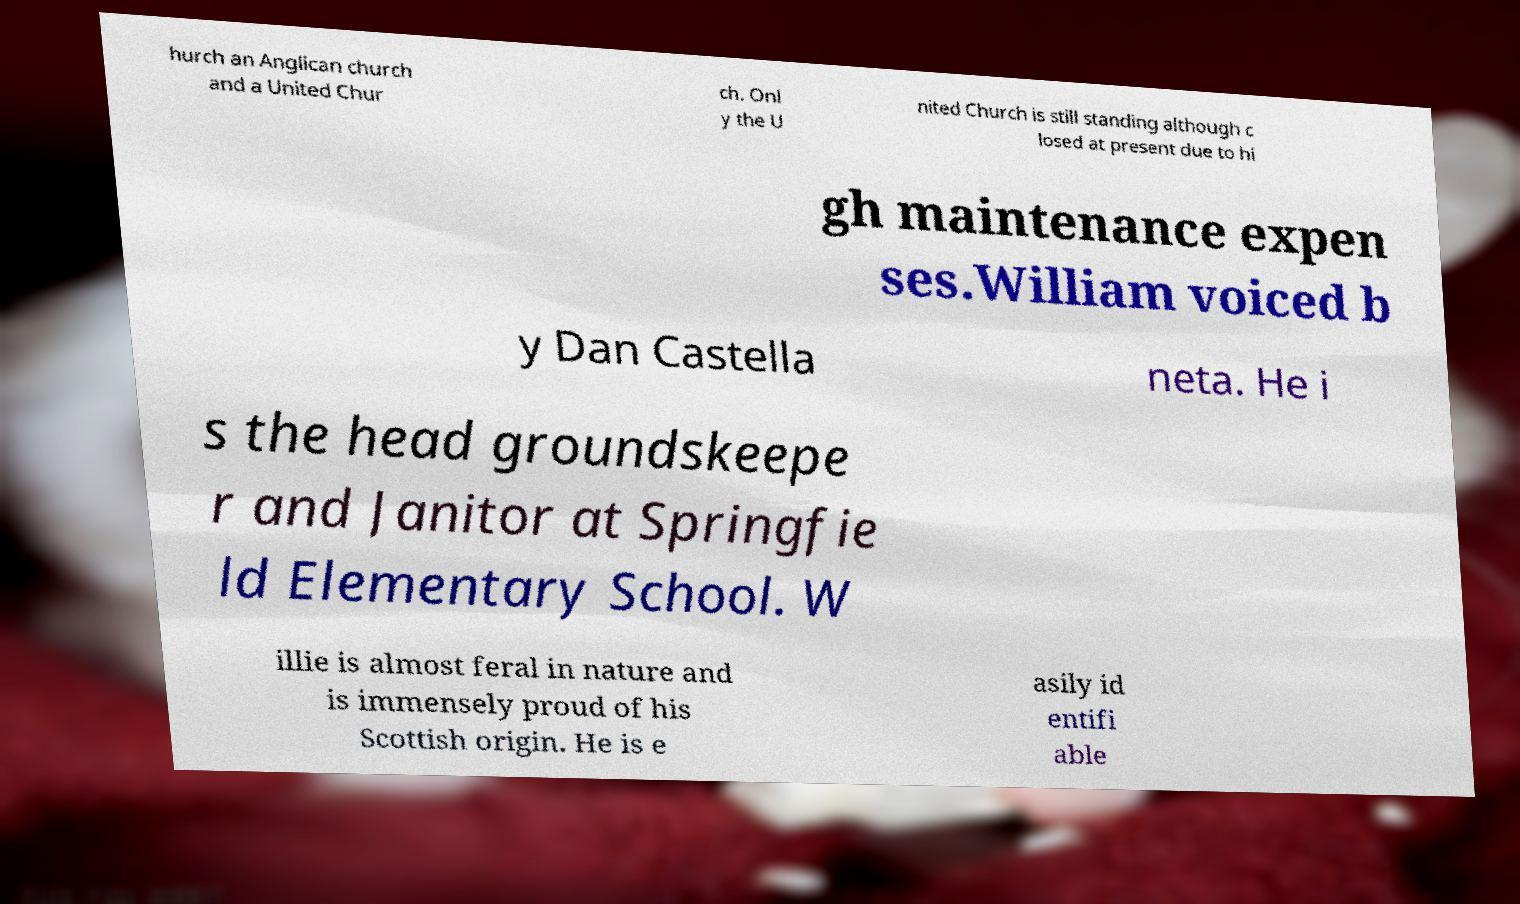Can you read and provide the text displayed in the image?This photo seems to have some interesting text. Can you extract and type it out for me? hurch an Anglican church and a United Chur ch. Onl y the U nited Church is still standing although c losed at present due to hi gh maintenance expen ses.William voiced b y Dan Castella neta. He i s the head groundskeepe r and Janitor at Springfie ld Elementary School. W illie is almost feral in nature and is immensely proud of his Scottish origin. He is e asily id entifi able 